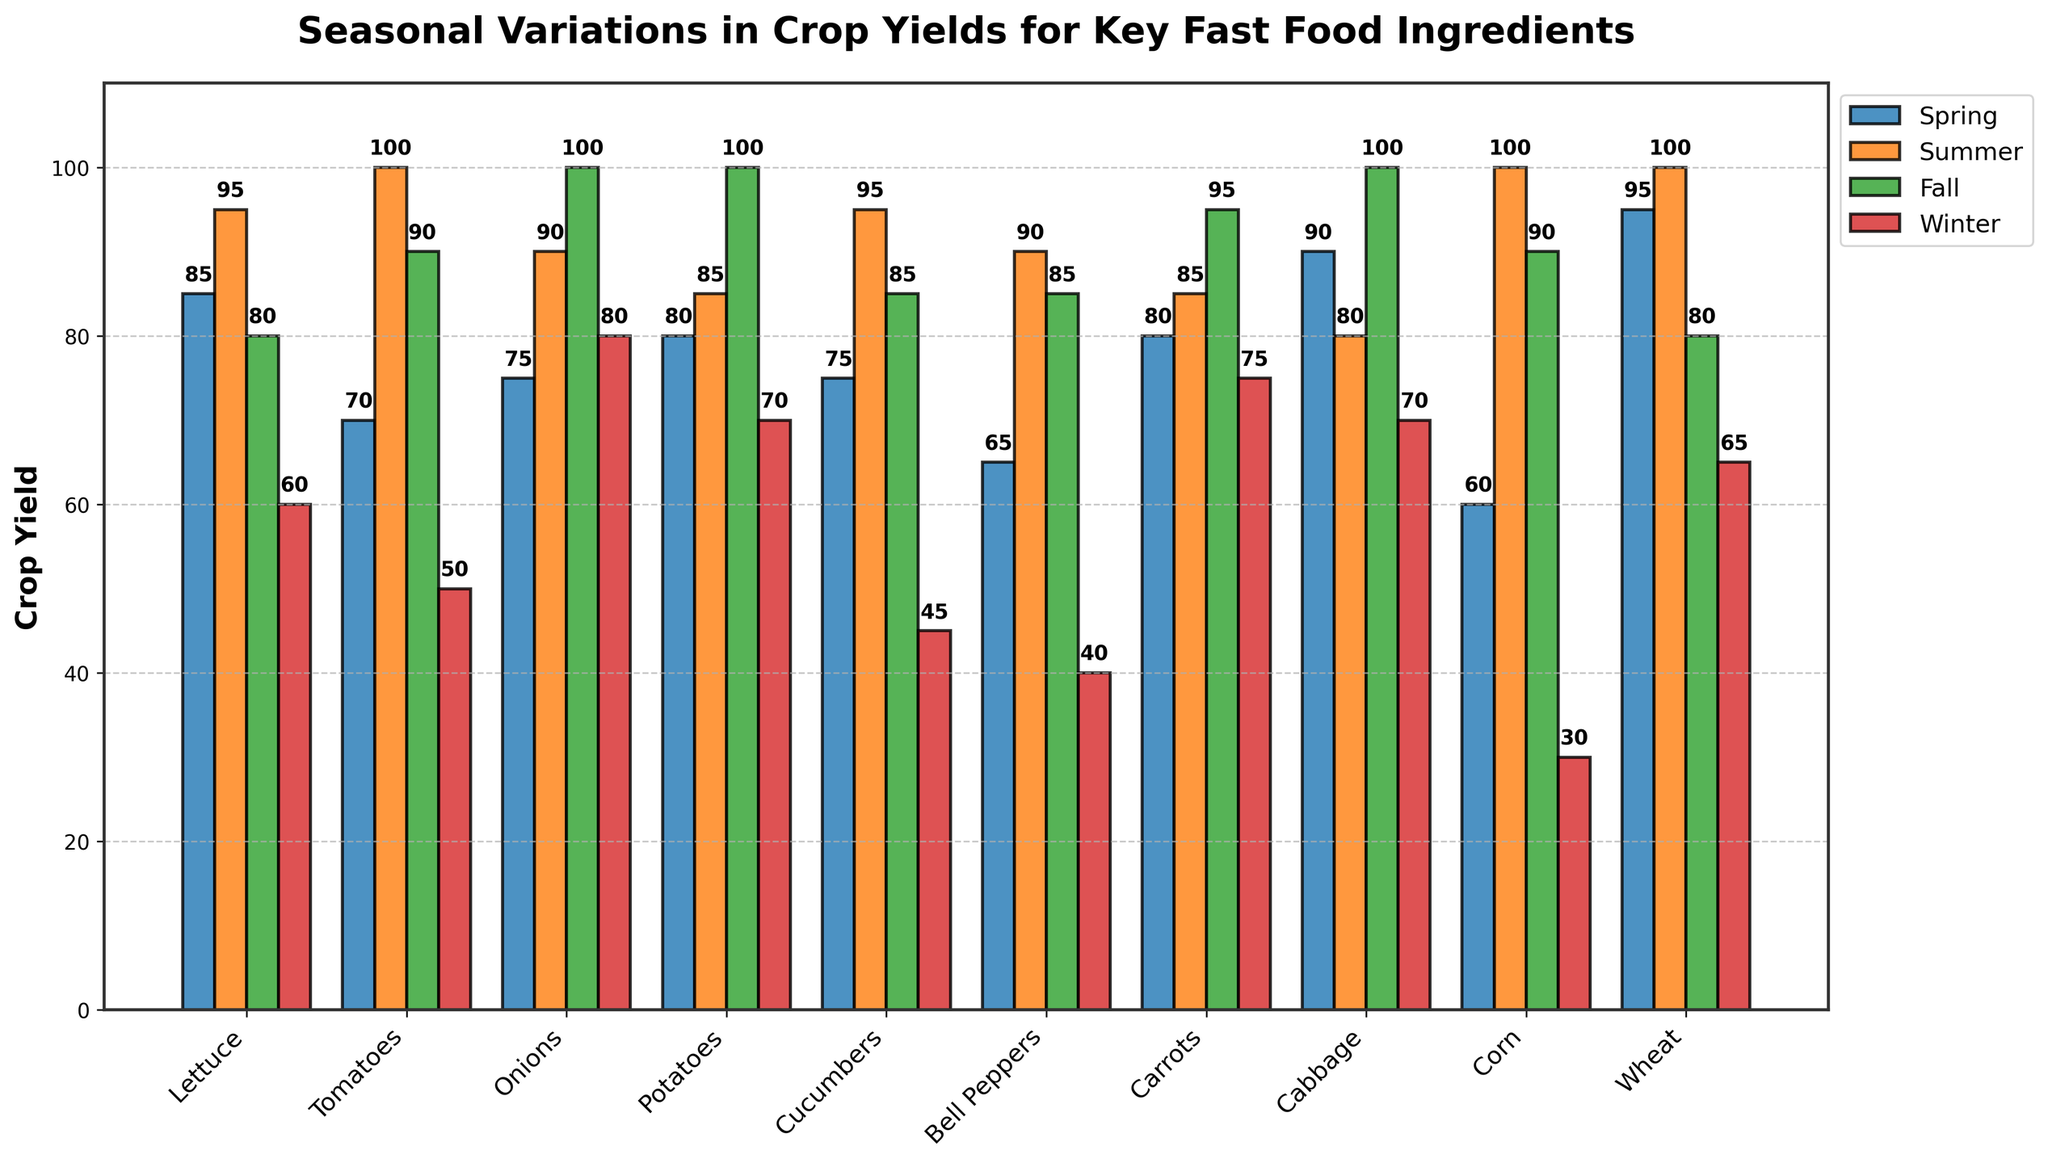Which ingredient has the highest crop yield in the Summer? Look for the tallest bar in the Summer section (light green) and check which ingredient it corresponds to. The tallest bar in the Summer is 100, which corresponds to Tomatoes, Corn, and Wheat. Compare their yields across other seasons to evaluate if they have the highest cumulative yield or just the highest in Summer.
Answer: Tomatoes, Corn, Wheat Which season has the lowest average crop yield? Calculate the average yield for each season by summing the values and dividing by the number of ingredients. Spring: (85+70+75+80+75+65+80+90+60+95)/10 = 77. Fall: (80+90+100+100+85+85+95+100+90+80)/10 = 90. Winter: (60+50+80+70+45+40+75+70+30+65)/10 = 58. Summer: (95+100+90+85+95+90+85+80+100+100)/10 = 92. The lowest average is in Winter.
Answer: Winter What is the total crop yield for Potatoes across all seasons? Sum the yields for Potatoes from each season. Spring: 80, Summer: 85, Fall: 100, Winter: 70. Total: 80 + 85 + 100 + 70 = 335.
Answer: 335 Which ingredient has the most variable crop yield across seasons? To identify the ingredient with the most variable crop yield, find the ingredient with the highest range (difference between the highest and lowest yields). Calculate the range for each ingredient: Lettuce: 95-60=35, Tomatoes: 100-50=50, Onions: 100-75=25, Potatoes: 100-70=30, Cucumbers: 95-45=50, Bell Peppers: 90-40=50, Carrots: 95-75=20, Cabbage: 100-70=30, Corn: 100-30=70, Wheat: 100-65=35. Corn has the highest range (70).
Answer: Corn Which ingredient has the highest combined yield in Spring and Winter? Sum the yields for each ingredient in Spring and Winter. Compare the sums: Lettuce: 85+60=145, Tomatoes: 70+50=120, Onions: 75+80=155, Potatoes: 80+70=150, Cucumbers: 75+45=120, Bell Peppers: 65+40=105, Carrots: 80+75=155, Cabbage: 90+70=160, Corn: 60+30=90, Wheat: 95+65=160. The highest combined yield is 160 for both Cabbage and Wheat.
Answer: Cabbage, Wheat 